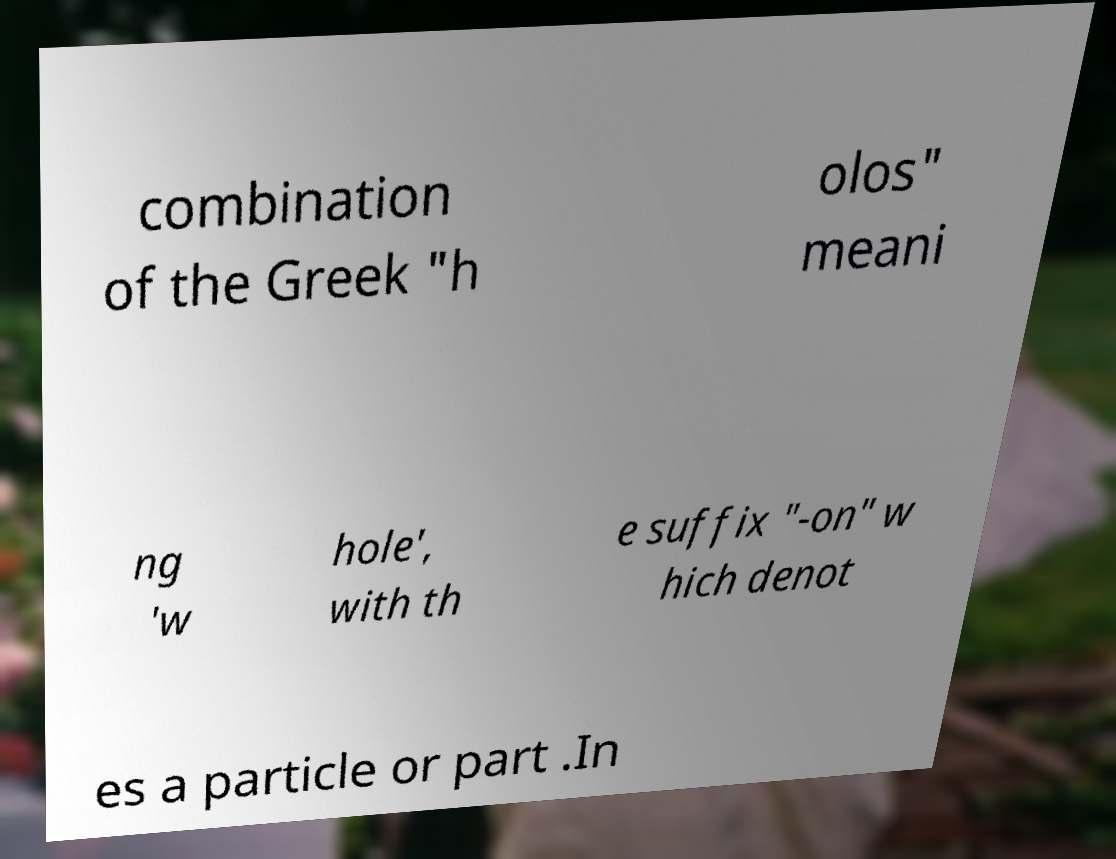Please read and relay the text visible in this image. What does it say? combination of the Greek "h olos" meani ng 'w hole', with th e suffix "-on" w hich denot es a particle or part .In 